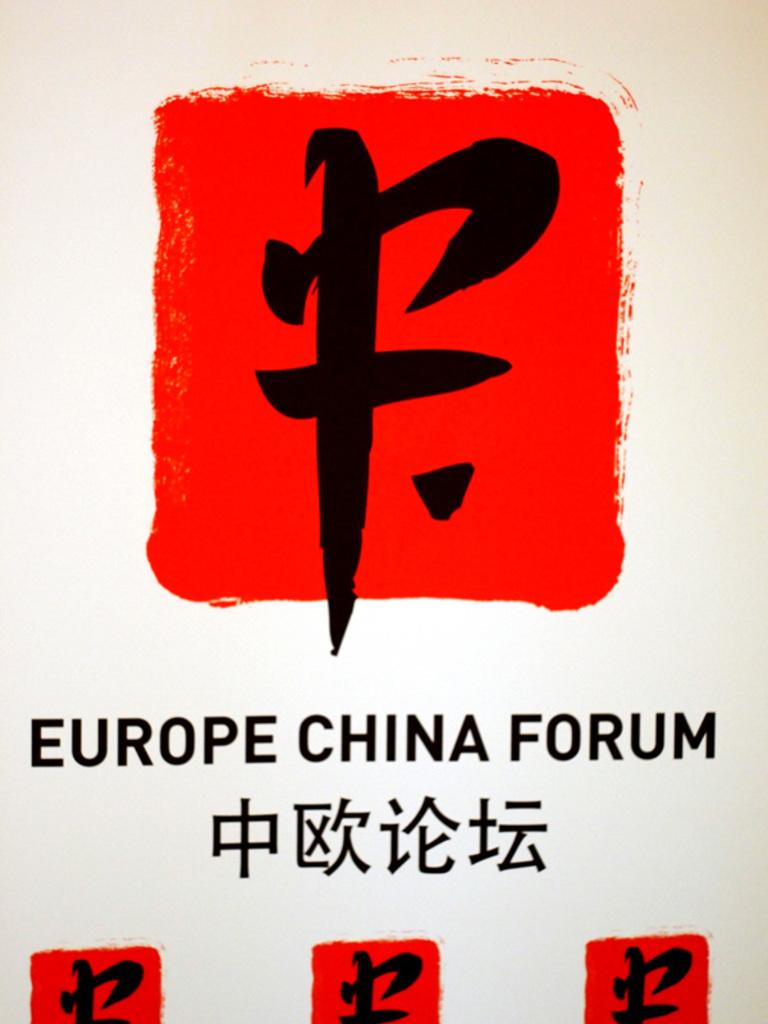What is wrote on the front?
Ensure brevity in your answer.  Europe china forum. 